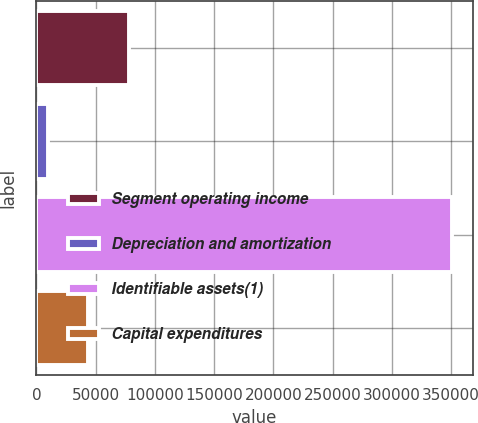<chart> <loc_0><loc_0><loc_500><loc_500><bar_chart><fcel>Segment operating income<fcel>Depreciation and amortization<fcel>Identifiable assets(1)<fcel>Capital expenditures<nl><fcel>77818.4<fcel>9568<fcel>350820<fcel>43693.2<nl></chart> 